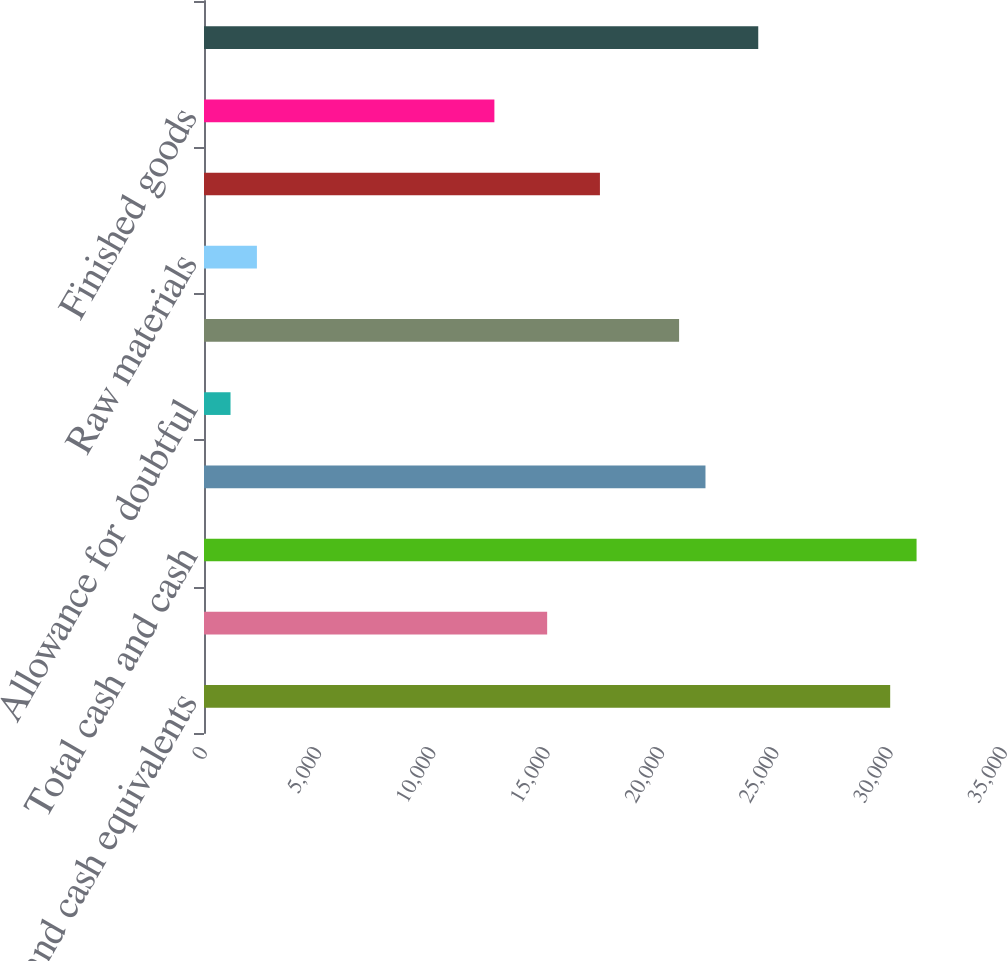<chart> <loc_0><loc_0><loc_500><loc_500><bar_chart><fcel>Cash and cash equivalents<fcel>Marketable securities<fcel>Total cash and cash<fcel>Accounts receivable<fcel>Allowance for doubtful<fcel>Total accounts receivable net<fcel>Raw materials<fcel>Work-in-process<fcel>Finished goods<fcel>Total inventories<nl><fcel>30020.4<fcel>15013.2<fcel>31174.8<fcel>21939.6<fcel>1160.4<fcel>20785.2<fcel>2314.8<fcel>17322<fcel>12704.4<fcel>24248.4<nl></chart> 